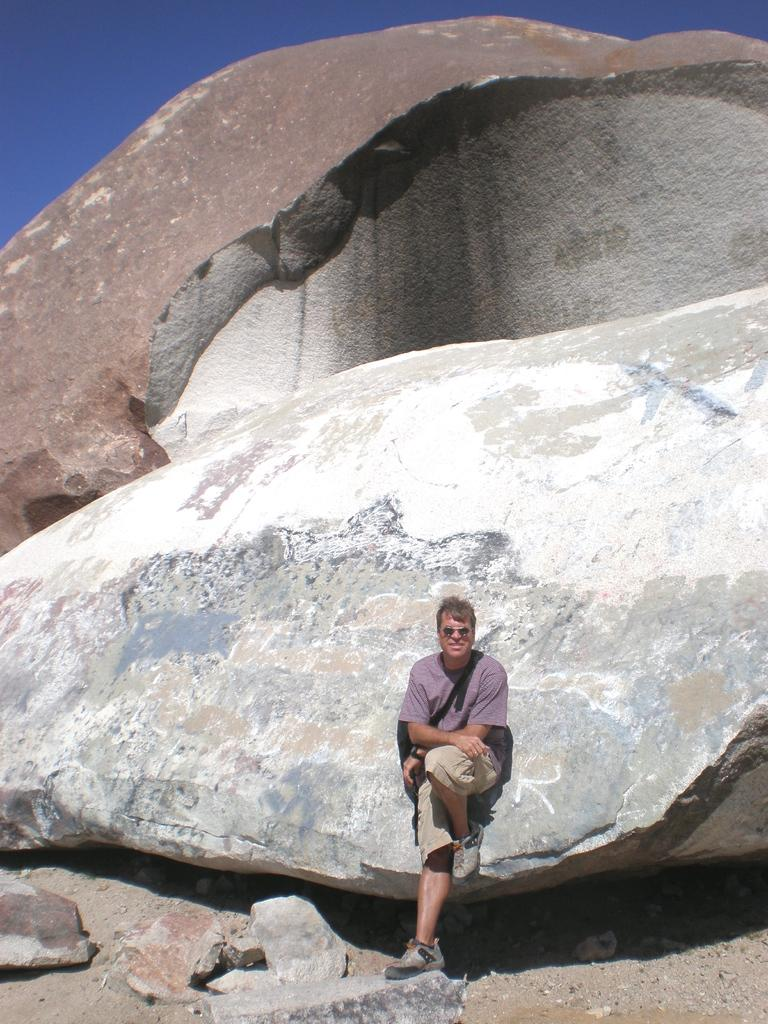Who is present in the image? There is a man in the image. What is the man standing beside? The man is standing beside a rock. What can be seen in the background of the image? The sky is visible in the background of the image. What type of clothing is the man wearing on his upper body? The man is wearing a t-shirt. What type of clothing is the man wearing on his lower body? The man is wearing shorts. What type of footwear is the man wearing? The man is wearing shoes. What type of muscle can be seen flexing in the image? There is no muscle flexing visible in the image; it only shows a man standing beside a rock. 